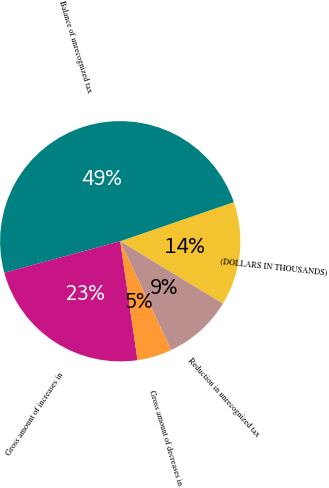Convert chart. <chart><loc_0><loc_0><loc_500><loc_500><pie_chart><fcel>(DOLLARS IN THOUSANDS)<fcel>Balance of unrecognized tax<fcel>Gross amount of increases in<fcel>Gross amount of decreases in<fcel>Reduction in unrecognized tax<nl><fcel>13.97%<fcel>48.94%<fcel>23.08%<fcel>4.68%<fcel>9.33%<nl></chart> 